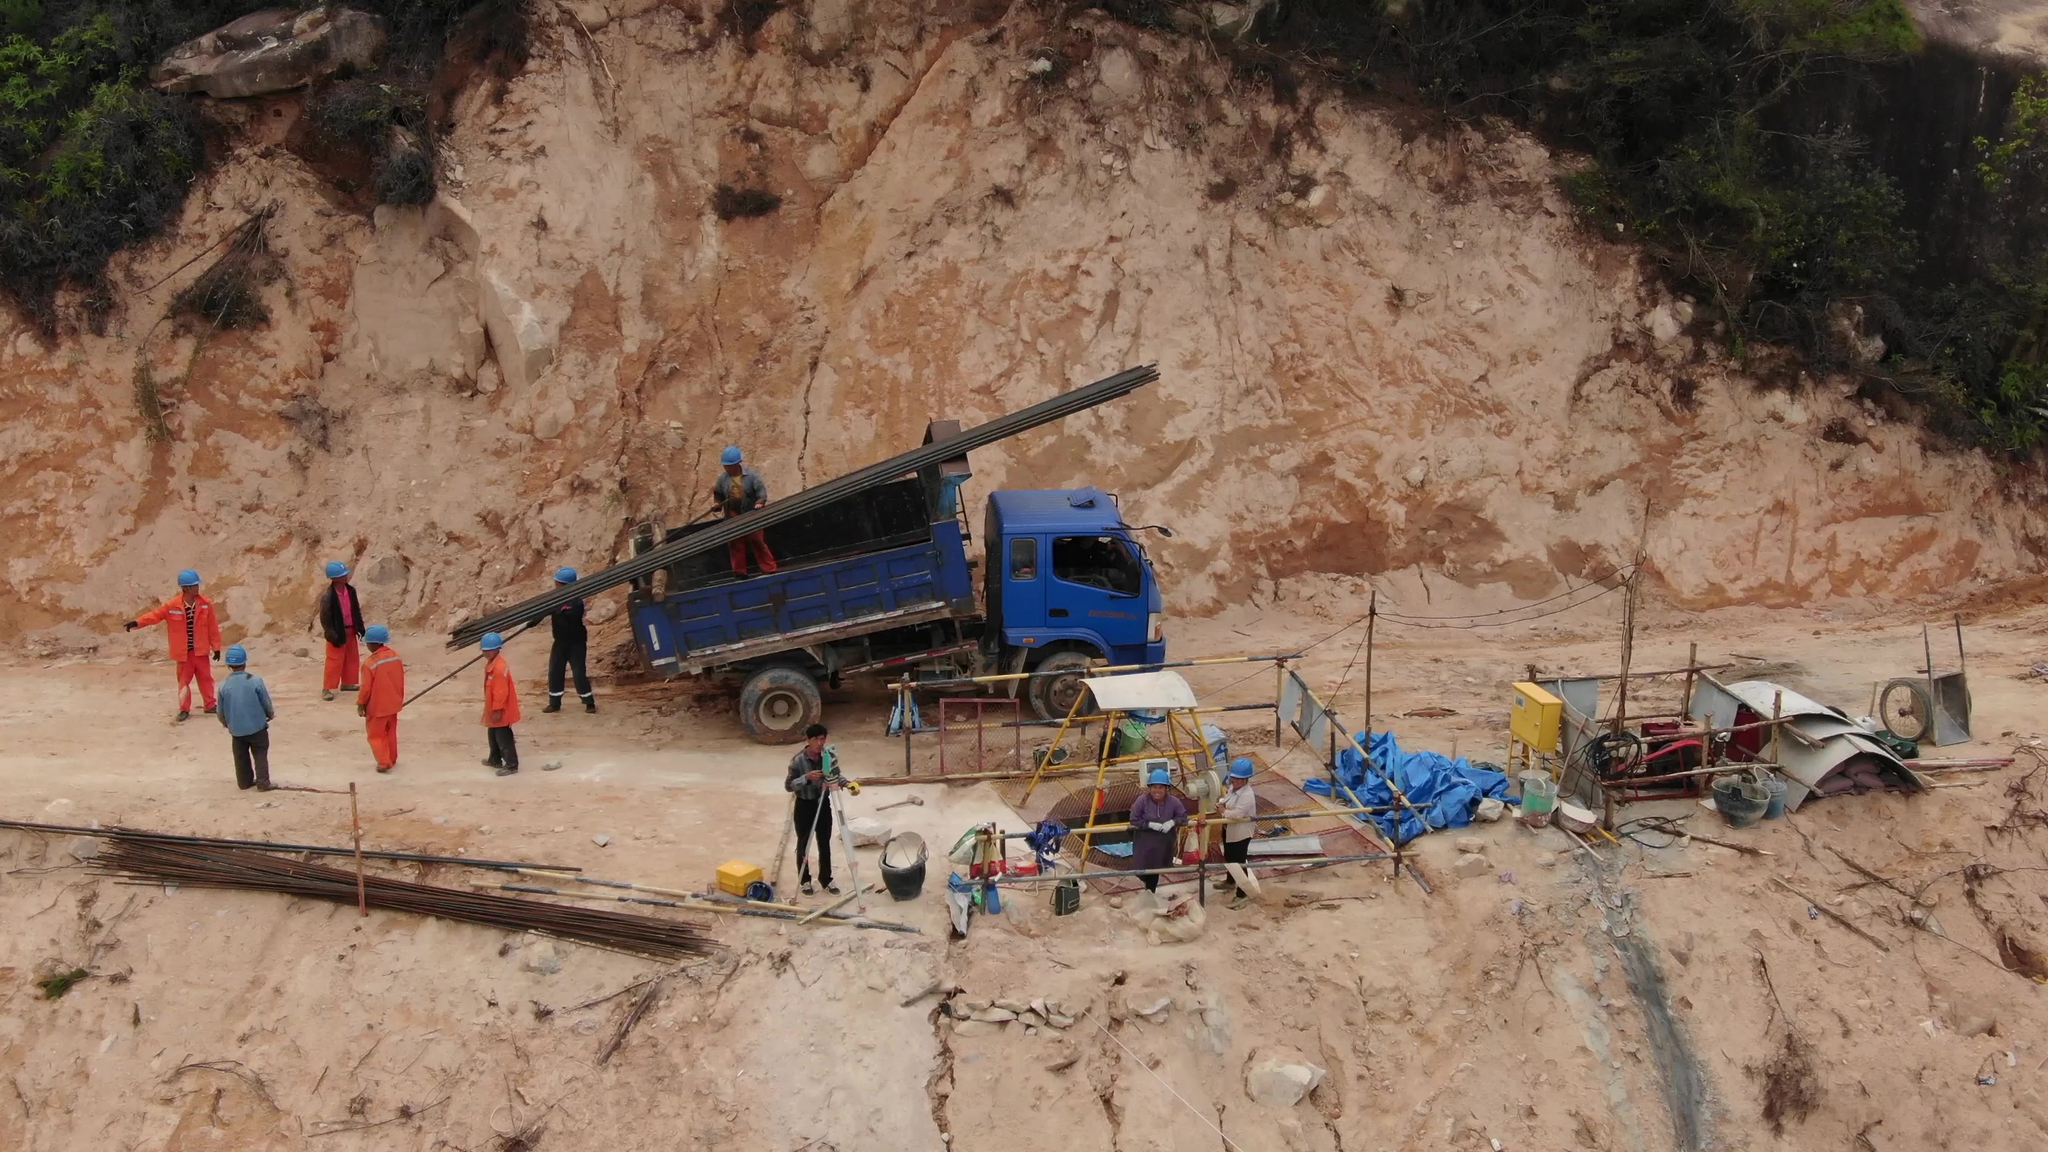Point out the person in the picture who is not wearing a helmet In the image, there is a person wearing a pink shirt and dark pants, standing near the center of the image to the right of a blue truck, who is not wearing a helmet. This individual is in contrast to the others around who are wearing helmets, presumably for safety reasons at this construction or work site. 